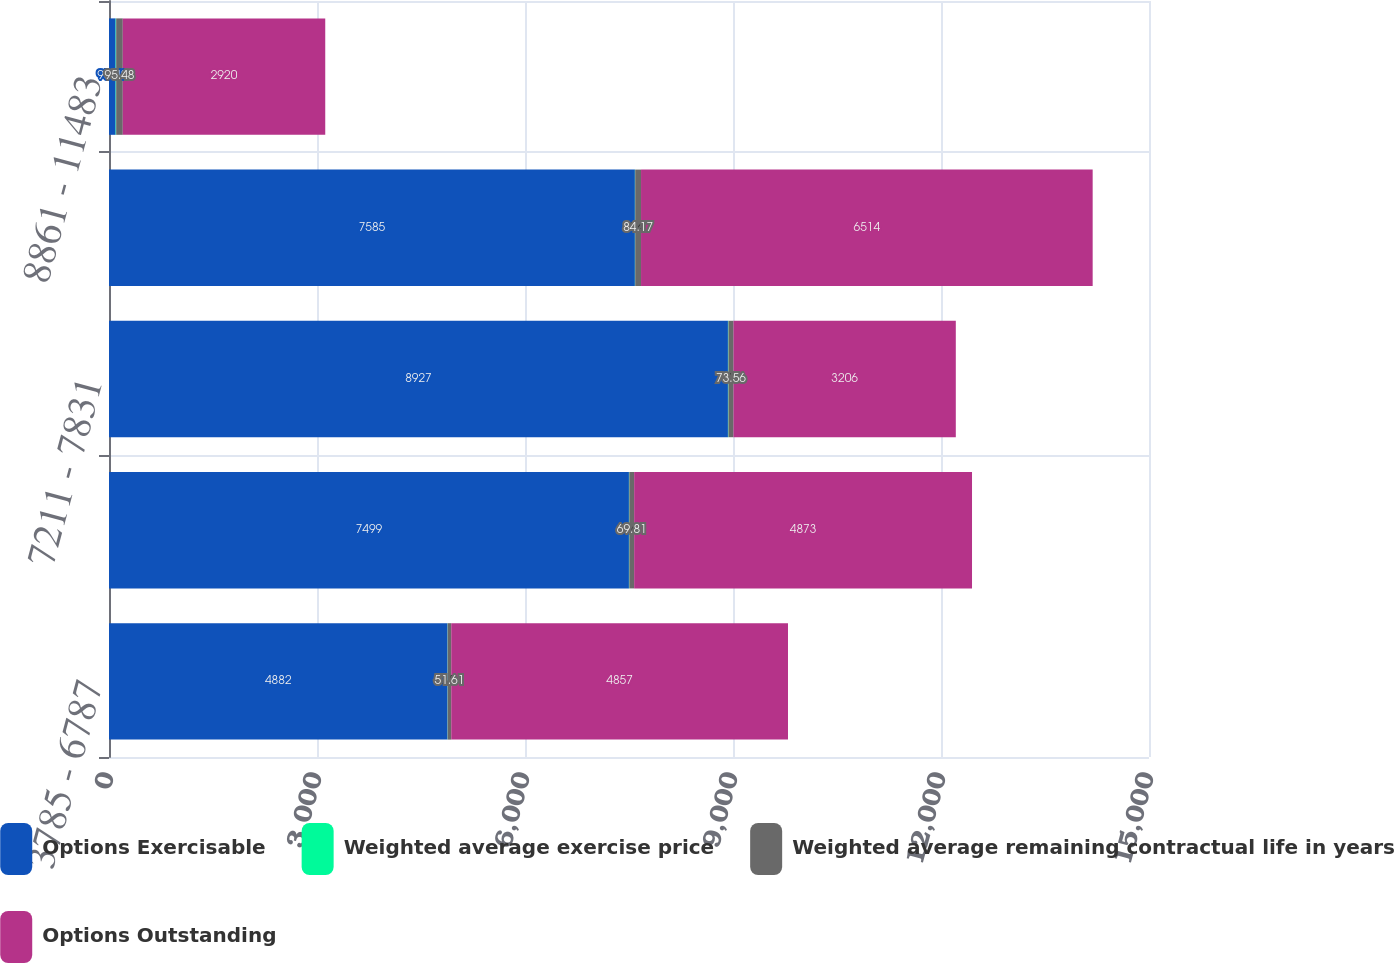<chart> <loc_0><loc_0><loc_500><loc_500><stacked_bar_chart><ecel><fcel>3785 - 6787<fcel>6851 - 7093<fcel>7211 - 7831<fcel>8388 - 8493<fcel>8861 - 11483<nl><fcel>Options Exercisable<fcel>4882<fcel>7499<fcel>8927<fcel>7585<fcel>95.48<nl><fcel>Weighted average exercise price<fcel>2.5<fcel>5.6<fcel>7<fcel>4.4<fcel>8<nl><fcel>Weighted average remaining contractual life in years<fcel>51.61<fcel>69.81<fcel>73.56<fcel>84.17<fcel>95.48<nl><fcel>Options Outstanding<fcel>4857<fcel>4873<fcel>3206<fcel>6514<fcel>2920<nl></chart> 